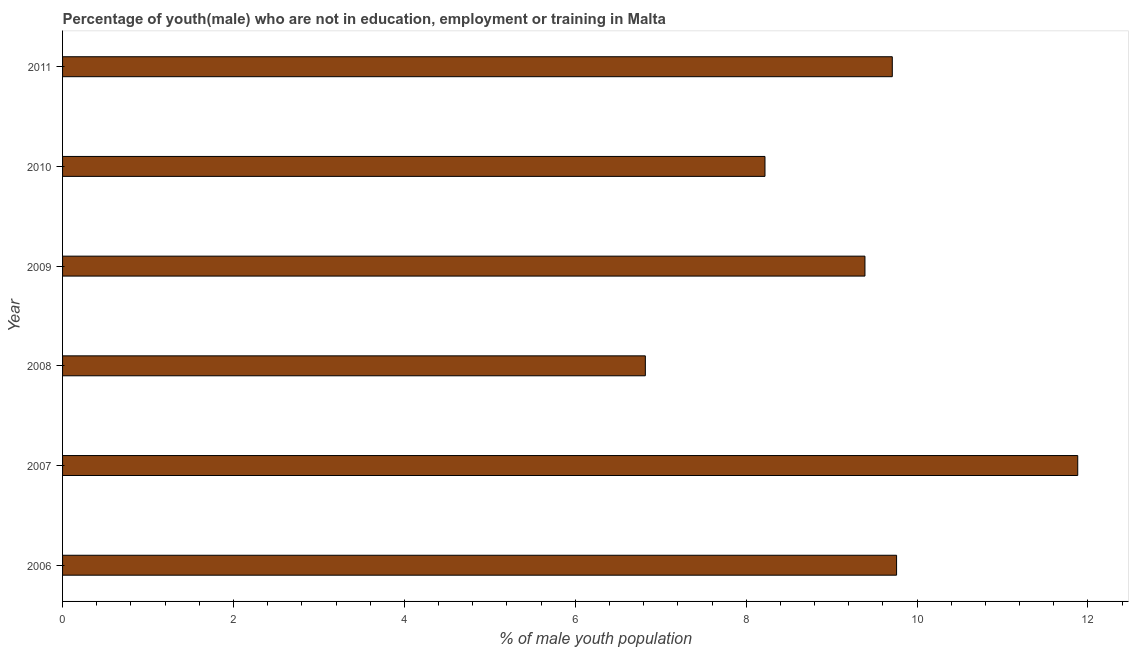What is the title of the graph?
Your response must be concise. Percentage of youth(male) who are not in education, employment or training in Malta. What is the label or title of the X-axis?
Your response must be concise. % of male youth population. What is the unemployed male youth population in 2010?
Make the answer very short. 8.22. Across all years, what is the maximum unemployed male youth population?
Your answer should be very brief. 11.88. Across all years, what is the minimum unemployed male youth population?
Offer a very short reply. 6.82. What is the sum of the unemployed male youth population?
Your answer should be compact. 55.78. What is the difference between the unemployed male youth population in 2007 and 2009?
Keep it short and to the point. 2.49. What is the average unemployed male youth population per year?
Offer a very short reply. 9.3. What is the median unemployed male youth population?
Keep it short and to the point. 9.55. In how many years, is the unemployed male youth population greater than 5.6 %?
Provide a succinct answer. 6. What is the ratio of the unemployed male youth population in 2009 to that in 2011?
Give a very brief answer. 0.97. Is the unemployed male youth population in 2006 less than that in 2009?
Your answer should be compact. No. Is the difference between the unemployed male youth population in 2009 and 2011 greater than the difference between any two years?
Your answer should be very brief. No. What is the difference between the highest and the second highest unemployed male youth population?
Offer a very short reply. 2.12. Is the sum of the unemployed male youth population in 2007 and 2008 greater than the maximum unemployed male youth population across all years?
Your answer should be very brief. Yes. What is the difference between the highest and the lowest unemployed male youth population?
Offer a very short reply. 5.06. How many bars are there?
Offer a very short reply. 6. What is the difference between two consecutive major ticks on the X-axis?
Provide a succinct answer. 2. What is the % of male youth population of 2006?
Your answer should be compact. 9.76. What is the % of male youth population in 2007?
Ensure brevity in your answer.  11.88. What is the % of male youth population in 2008?
Your answer should be very brief. 6.82. What is the % of male youth population of 2009?
Your answer should be very brief. 9.39. What is the % of male youth population in 2010?
Offer a very short reply. 8.22. What is the % of male youth population in 2011?
Your answer should be very brief. 9.71. What is the difference between the % of male youth population in 2006 and 2007?
Provide a succinct answer. -2.12. What is the difference between the % of male youth population in 2006 and 2008?
Ensure brevity in your answer.  2.94. What is the difference between the % of male youth population in 2006 and 2009?
Provide a succinct answer. 0.37. What is the difference between the % of male youth population in 2006 and 2010?
Offer a terse response. 1.54. What is the difference between the % of male youth population in 2007 and 2008?
Offer a terse response. 5.06. What is the difference between the % of male youth population in 2007 and 2009?
Offer a terse response. 2.49. What is the difference between the % of male youth population in 2007 and 2010?
Keep it short and to the point. 3.66. What is the difference between the % of male youth population in 2007 and 2011?
Offer a terse response. 2.17. What is the difference between the % of male youth population in 2008 and 2009?
Offer a terse response. -2.57. What is the difference between the % of male youth population in 2008 and 2011?
Your response must be concise. -2.89. What is the difference between the % of male youth population in 2009 and 2010?
Make the answer very short. 1.17. What is the difference between the % of male youth population in 2009 and 2011?
Offer a terse response. -0.32. What is the difference between the % of male youth population in 2010 and 2011?
Your answer should be very brief. -1.49. What is the ratio of the % of male youth population in 2006 to that in 2007?
Provide a succinct answer. 0.82. What is the ratio of the % of male youth population in 2006 to that in 2008?
Give a very brief answer. 1.43. What is the ratio of the % of male youth population in 2006 to that in 2009?
Provide a succinct answer. 1.04. What is the ratio of the % of male youth population in 2006 to that in 2010?
Make the answer very short. 1.19. What is the ratio of the % of male youth population in 2006 to that in 2011?
Give a very brief answer. 1. What is the ratio of the % of male youth population in 2007 to that in 2008?
Offer a very short reply. 1.74. What is the ratio of the % of male youth population in 2007 to that in 2009?
Provide a short and direct response. 1.26. What is the ratio of the % of male youth population in 2007 to that in 2010?
Your answer should be compact. 1.45. What is the ratio of the % of male youth population in 2007 to that in 2011?
Your answer should be compact. 1.22. What is the ratio of the % of male youth population in 2008 to that in 2009?
Your answer should be compact. 0.73. What is the ratio of the % of male youth population in 2008 to that in 2010?
Your response must be concise. 0.83. What is the ratio of the % of male youth population in 2008 to that in 2011?
Make the answer very short. 0.7. What is the ratio of the % of male youth population in 2009 to that in 2010?
Your response must be concise. 1.14. What is the ratio of the % of male youth population in 2009 to that in 2011?
Your response must be concise. 0.97. What is the ratio of the % of male youth population in 2010 to that in 2011?
Give a very brief answer. 0.85. 